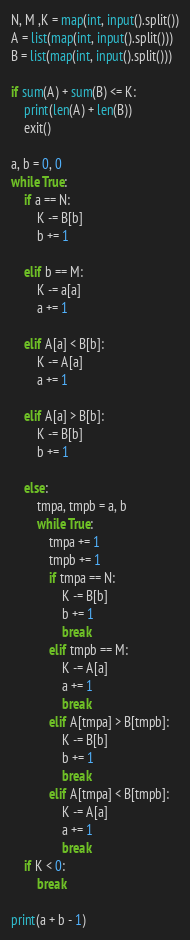Convert code to text. <code><loc_0><loc_0><loc_500><loc_500><_Python_>N, M ,K = map(int, input().split())
A = list(map(int, input().split()))
B = list(map(int, input().split()))

if sum(A) + sum(B) <= K:
    print(len(A) + len(B))
    exit()

a, b = 0, 0
while True:
    if a == N:
        K -= B[b]
        b += 1
    
    elif b == M:
        K -= a[a]
        a += 1

    elif A[a] < B[b]:
        K -= A[a]
        a += 1
    
    elif A[a] > B[b]:
        K -= B[b]
        b += 1

    else:
        tmpa, tmpb = a, b
        while True:
            tmpa += 1
            tmpb += 1
            if tmpa == N:
                K -= B[b]
                b += 1
                break
            elif tmpb == M:
                K -= A[a]
                a += 1
                break
            elif A[tmpa] > B[tmpb]:
                K -= B[b]
                b += 1
                break
            elif A[tmpa] < B[tmpb]:
                K -= A[a]
                a += 1
                break 
    if K < 0:
        break

print(a + b - 1)</code> 